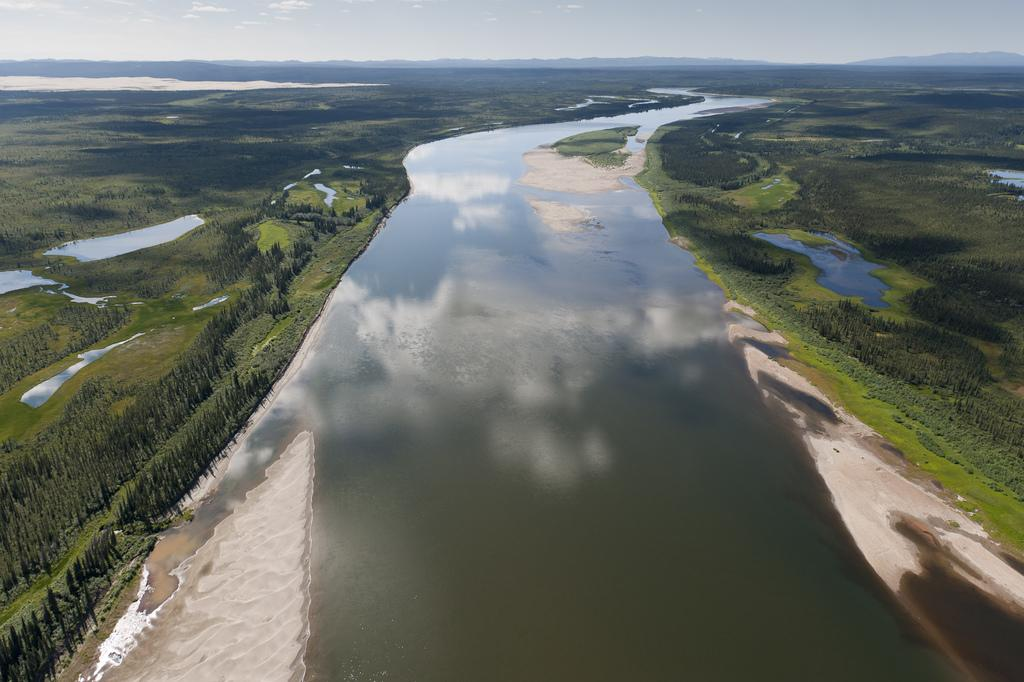What is the main feature in the middle of the image? There is a river in the middle of the image. What can be seen on either side of the river? There are plants and grass on either side of the river. What is visible at the top of the image? The sky is visible at the top of the image. Are there any dinosaurs visible in the image? No, there are no dinosaurs present in the image. What type of bubble can be seen floating near the river? There is no bubble visible in the image. 